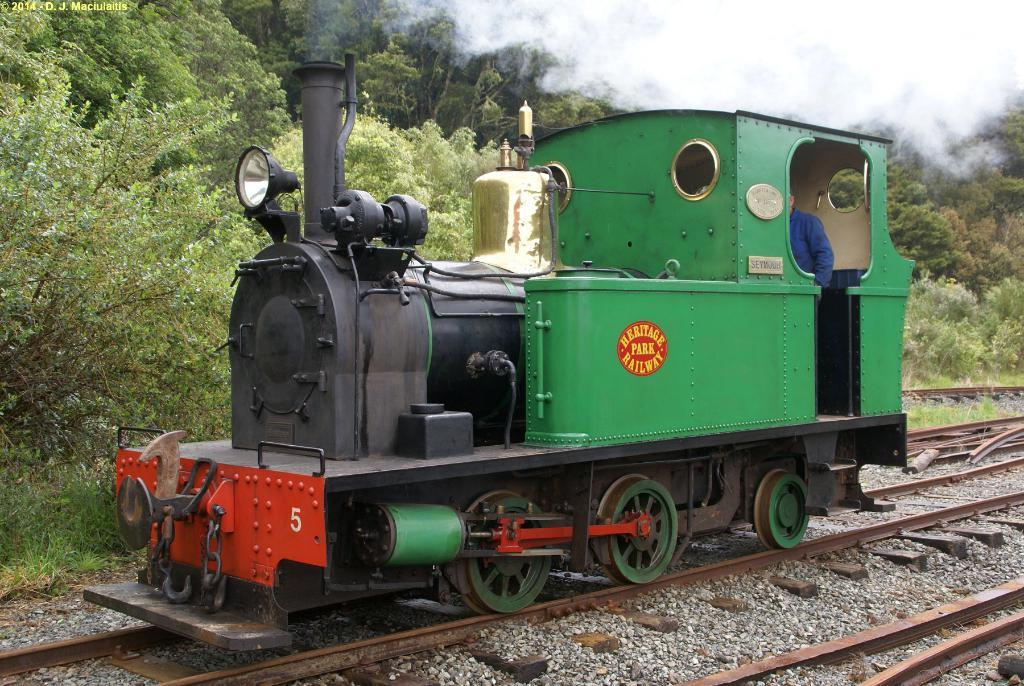What is the man doing in the image? There is a man in the railway engine. What can be seen in the background of the image? The railway track is visible in the image. What type of natural elements are present in the image? Stones and trees are visible in the image. What is the result of the railway engine's activity in the image? There is smoke in the image. What type of prose is the man reading in the railway engine? There is no indication in the image that the man is reading any prose, as the focus is on his presence in the railway engine and the smoke produced by the engine. 